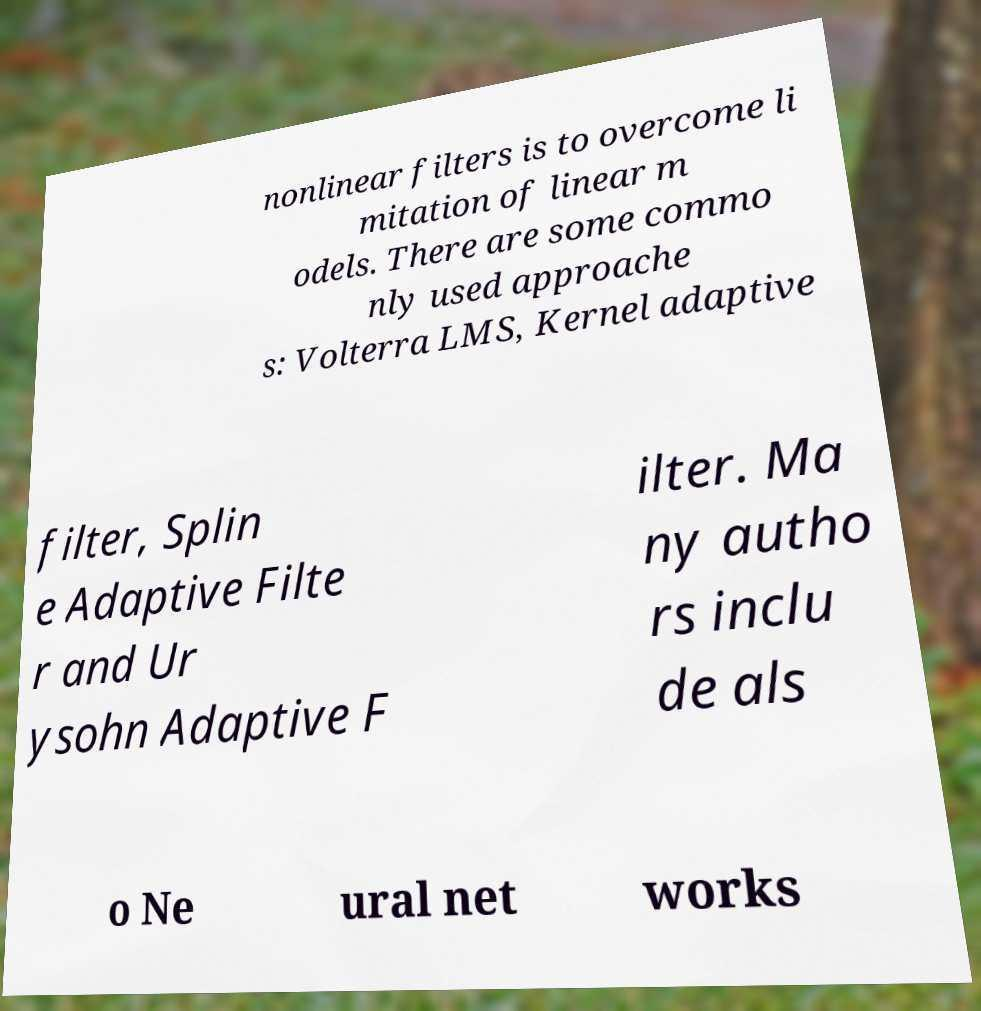There's text embedded in this image that I need extracted. Can you transcribe it verbatim? nonlinear filters is to overcome li mitation of linear m odels. There are some commo nly used approache s: Volterra LMS, Kernel adaptive filter, Splin e Adaptive Filte r and Ur ysohn Adaptive F ilter. Ma ny autho rs inclu de als o Ne ural net works 